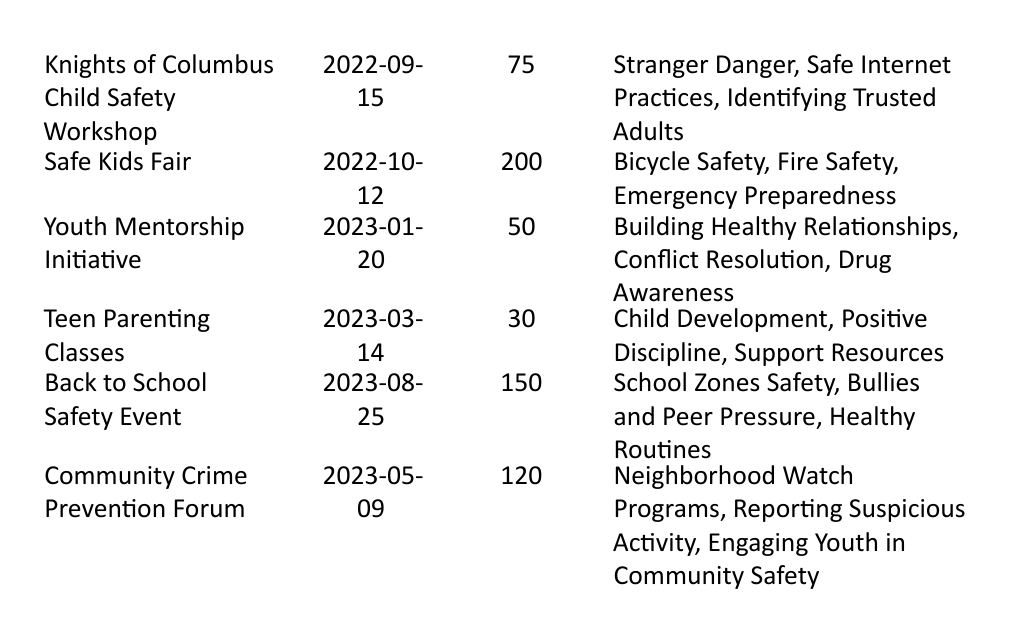What is the total number of participants in all programs? To find the total number of participants, we need to add the participant counts from all the programs listed: 75 + 200 + 50 + 30 + 150 + 120 = 625.
Answer: 625 Which program had the highest number of participants? From the table, we see that the "Safe Kids Fair" had 200 participants, which is the highest compared to the others.
Answer: Safe Kids Fair How many programs were conducted in 2023? Looking at the dates, there are three programs listed in 2023: "Youth Mentorship Initiative," "Teen Parenting Classes," and "Back to School Safety Event."
Answer: 3 Does the "Teen Parenting Classes" cover topics related to safety? The topics covered in the "Teen Parenting Classes" are "Child Development," "Positive Discipline," and "Support Resources." None of these topics explicitly relate to safety, so the answer is no.
Answer: No What is the average number of participants per program? First, we have 6 programs in total. The total number of participants is 625. To get the average, we divide the total participants by the number of programs: 625 / 6 = 104.1667. Rounding gives us an average of approximately 104.
Answer: 104 Which program took place at the Springfield Community Center? The program that took place at the Springfield Community Center is the "Knights of Columbus Child Safety Workshop," which occurred on 2022-09-15.
Answer: Knights of Columbus Child Safety Workshop Are there any programs that cover topics on "Drug Awareness"? The "Youth Mentorship Initiative" covers "Drug Awareness" among other topics, indicating that there is indeed a program addressing this issue.
Answer: Yes What is the difference in the number of participants between the "Back to School Safety Event" and the "Teen Parenting Classes"? The "Back to School Safety Event" had 150 participants while the "Teen Parenting Classes" had 30. The difference is calculated as 150 - 30 = 120.
Answer: 120 How many programs were held in locations that have a community-centered theme (like community centers or schools)? Programs that fit this theme include: "Knights of Columbus Child Safety Workshop," "Youth Mentorship Initiative," "Teen Parenting Classes," and "Back to School Safety Event," making a total of four programs.
Answer: 4 